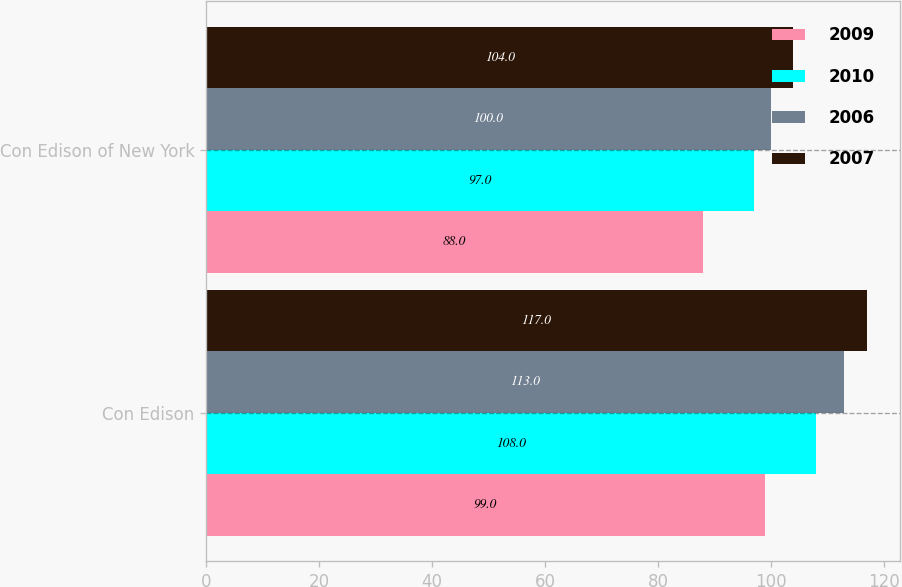Convert chart to OTSL. <chart><loc_0><loc_0><loc_500><loc_500><stacked_bar_chart><ecel><fcel>Con Edison<fcel>Con Edison of New York<nl><fcel>2009<fcel>99<fcel>88<nl><fcel>2010<fcel>108<fcel>97<nl><fcel>2006<fcel>113<fcel>100<nl><fcel>2007<fcel>117<fcel>104<nl></chart> 